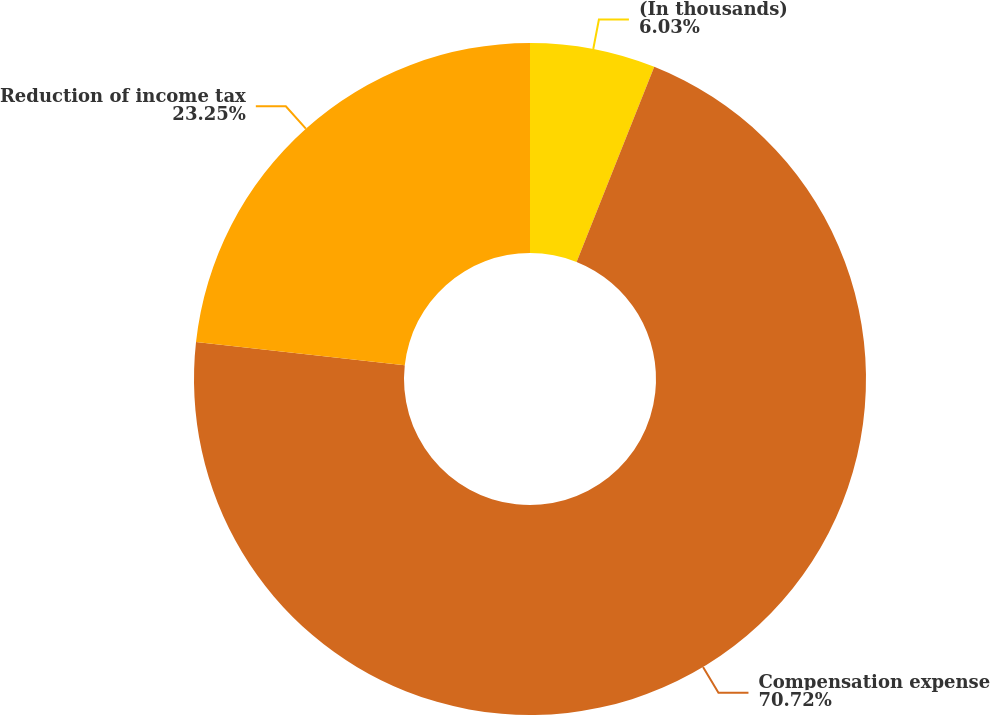Convert chart to OTSL. <chart><loc_0><loc_0><loc_500><loc_500><pie_chart><fcel>(In thousands)<fcel>Compensation expense<fcel>Reduction of income tax<nl><fcel>6.03%<fcel>70.73%<fcel>23.25%<nl></chart> 